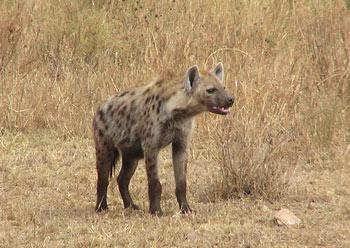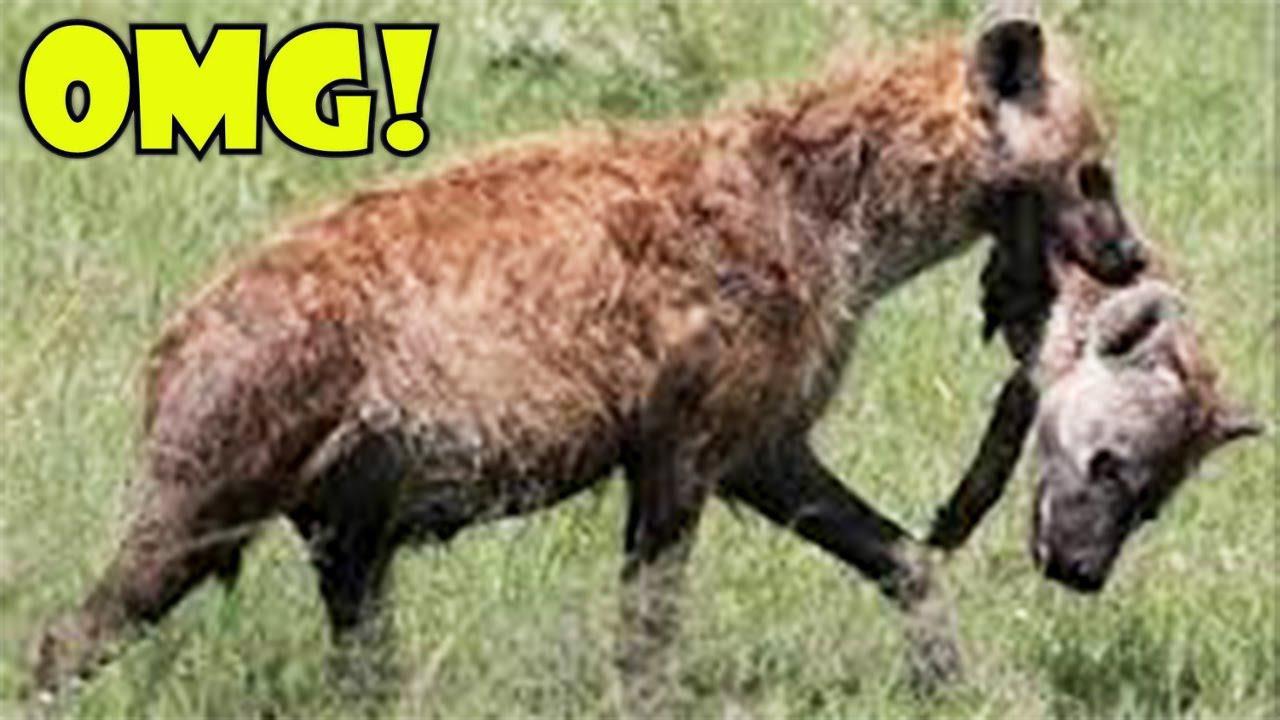The first image is the image on the left, the second image is the image on the right. Assess this claim about the two images: "There are atleast 4 Hyenas total". Correct or not? Answer yes or no. No. The first image is the image on the left, the second image is the image on the right. Analyze the images presented: Is the assertion "At least one image includes two hyenas fighting each other, with some bared fangs showing." valid? Answer yes or no. No. 